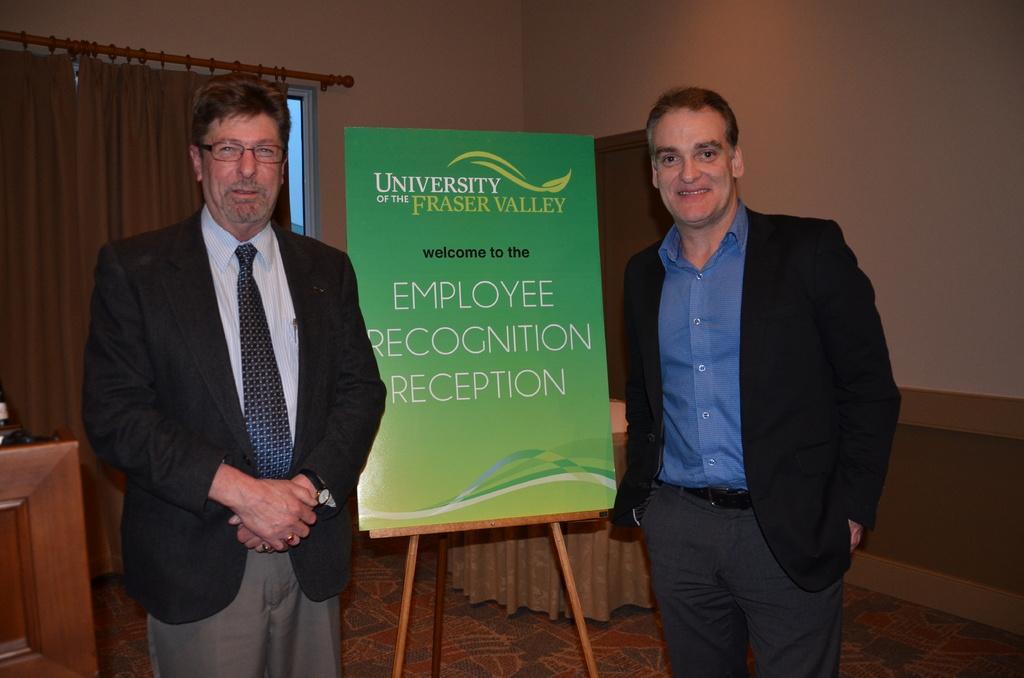Please provide a concise description of this image. In this picture we can see there are two people standing on the floor and behind the people there is a stand with a board, a wall with a window and curtain and other things. 